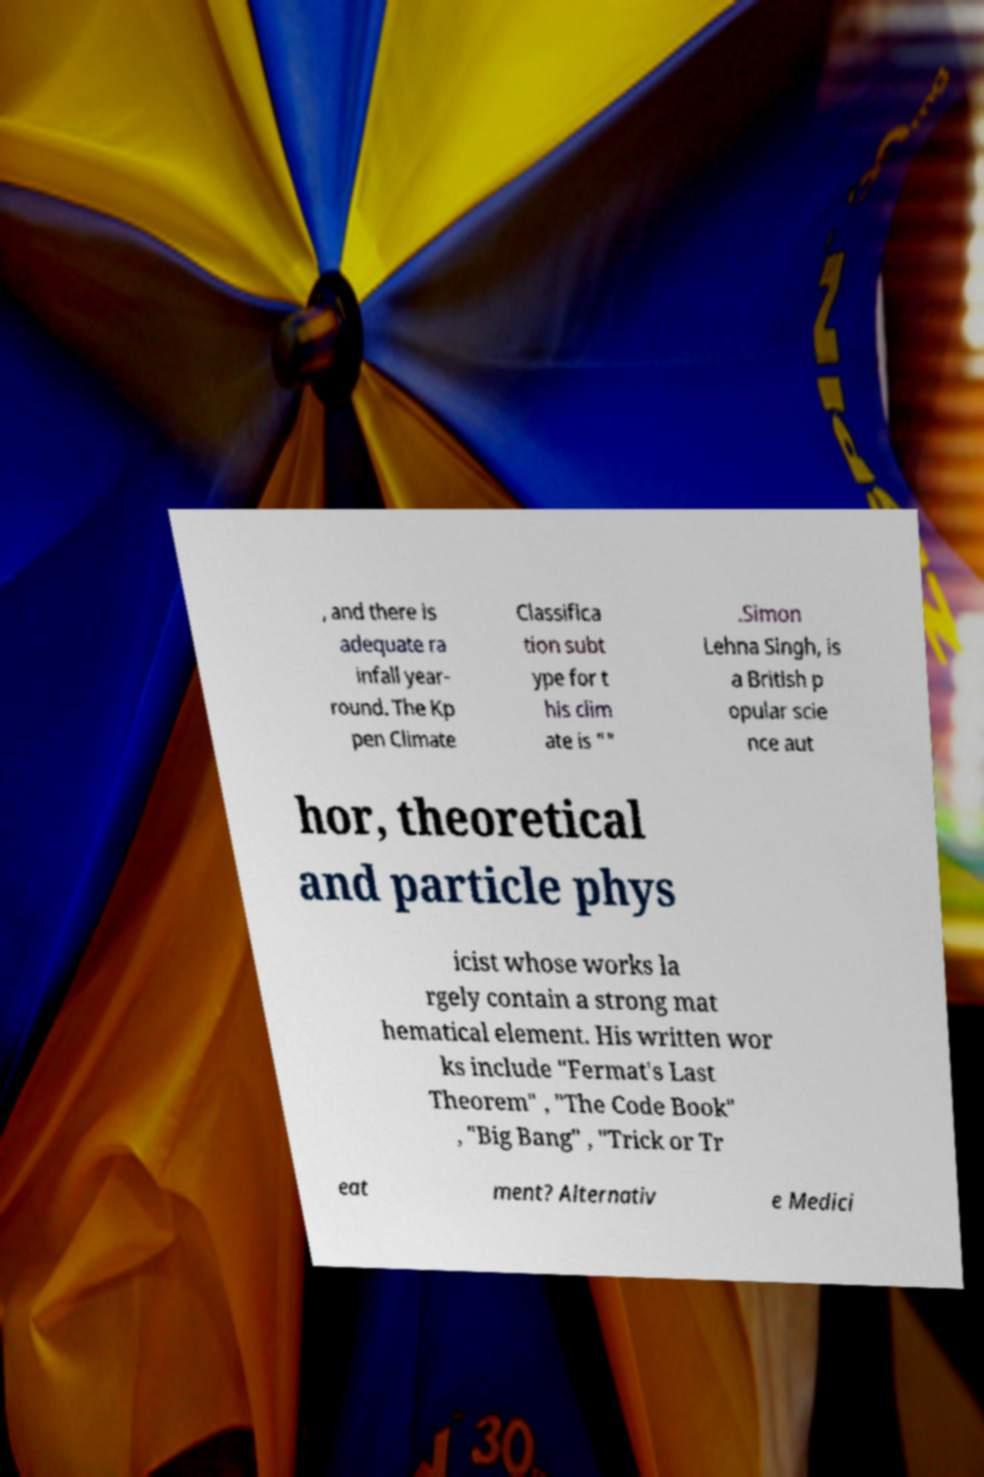For documentation purposes, I need the text within this image transcribed. Could you provide that? , and there is adequate ra infall year- round. The Kp pen Climate Classifica tion subt ype for t his clim ate is "" .Simon Lehna Singh, is a British p opular scie nce aut hor, theoretical and particle phys icist whose works la rgely contain a strong mat hematical element. His written wor ks include "Fermat's Last Theorem" , "The Code Book" , "Big Bang" , "Trick or Tr eat ment? Alternativ e Medici 